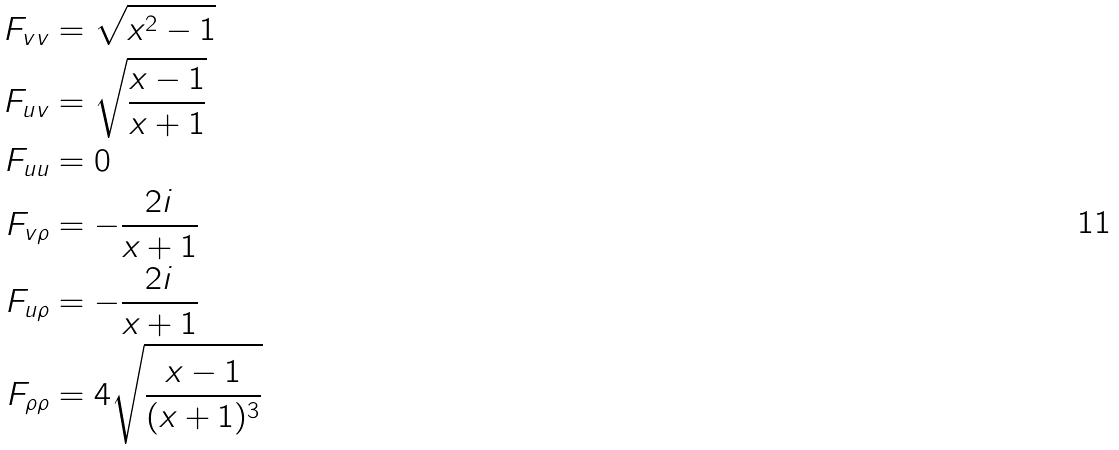<formula> <loc_0><loc_0><loc_500><loc_500>F _ { v v } & = \sqrt { x ^ { 2 } - 1 } \\ F _ { u v } & = \sqrt { \frac { x - 1 } { x + 1 } } \\ F _ { u u } & = 0 \\ F _ { v \rho } & = - \frac { 2 i } { x + 1 } \\ F _ { u \rho } & = - \frac { 2 i } { x + 1 } \\ F _ { \rho \rho } & = 4 \sqrt { \frac { x - 1 } { ( x + 1 ) ^ { 3 } } }</formula> 